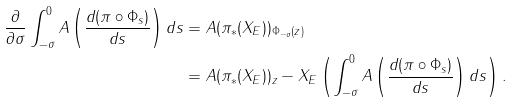<formula> <loc_0><loc_0><loc_500><loc_500>\frac { \partial } { \partial \sigma } \int _ { - \sigma } ^ { 0 } A \left ( \frac { d ( \pi \circ \Phi _ { s } ) } { d s } \right ) d s & = A ( \pi _ { \ast } ( X _ { E } ) ) _ { \Phi _ { - \sigma } ( z ) } \\ & = A ( \pi _ { \ast } ( X _ { E } ) ) _ { z } - X _ { E } \left ( \int _ { - \sigma } ^ { 0 } A \left ( \frac { d ( \pi \circ \Phi _ { s } ) } { d s } \right ) d s \right ) .</formula> 